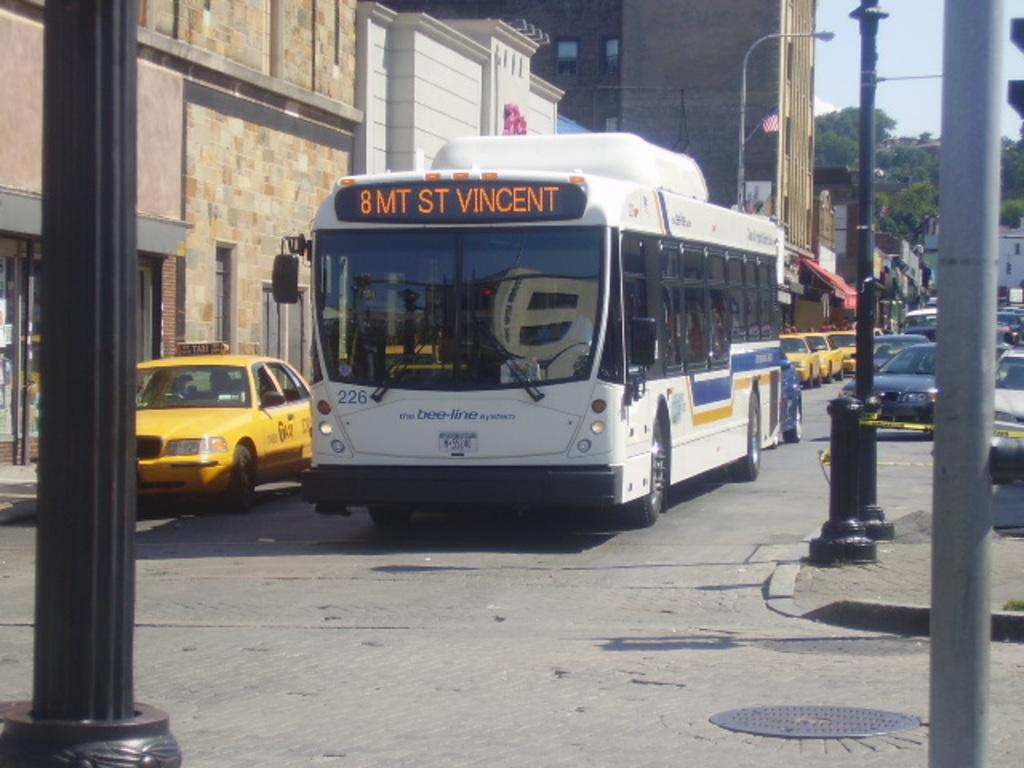Provide a one-sentence caption for the provided image. The bus is going to St. Vincent now. 